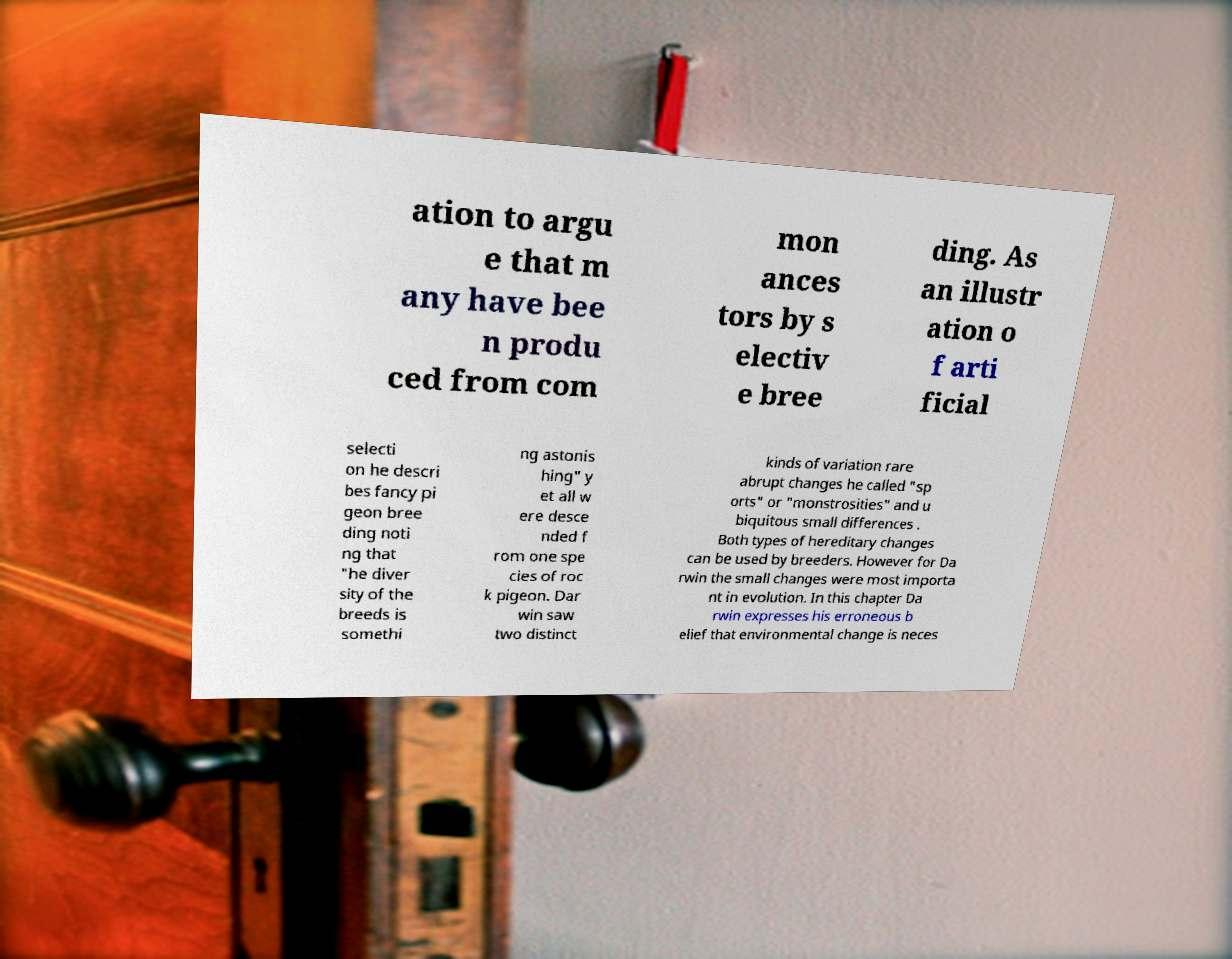Please identify and transcribe the text found in this image. ation to argu e that m any have bee n produ ced from com mon ances tors by s electiv e bree ding. As an illustr ation o f arti ficial selecti on he descri bes fancy pi geon bree ding noti ng that "he diver sity of the breeds is somethi ng astonis hing" y et all w ere desce nded f rom one spe cies of roc k pigeon. Dar win saw two distinct kinds of variation rare abrupt changes he called "sp orts" or "monstrosities" and u biquitous small differences . Both types of hereditary changes can be used by breeders. However for Da rwin the small changes were most importa nt in evolution. In this chapter Da rwin expresses his erroneous b elief that environmental change is neces 